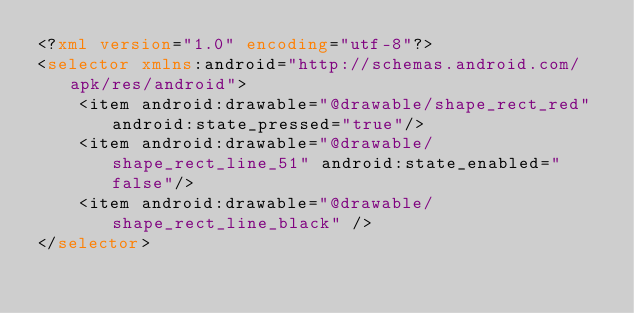Convert code to text. <code><loc_0><loc_0><loc_500><loc_500><_XML_><?xml version="1.0" encoding="utf-8"?>
<selector xmlns:android="http://schemas.android.com/apk/res/android">
	<item android:drawable="@drawable/shape_rect_red" android:state_pressed="true"/>
	<item android:drawable="@drawable/shape_rect_line_51" android:state_enabled="false"/>
	<item android:drawable="@drawable/shape_rect_line_black" />
</selector></code> 